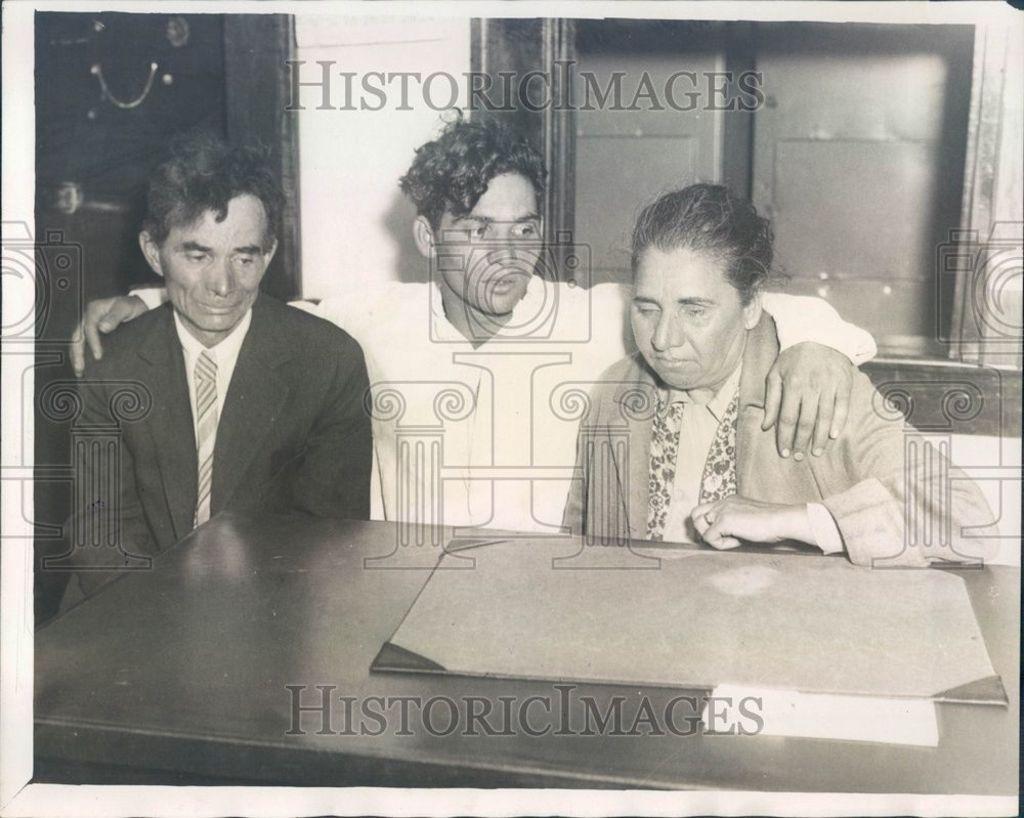How would you summarize this image in a sentence or two? In this image, there is a table and there are some people sitting, in the background there is a wall and there is a door. 